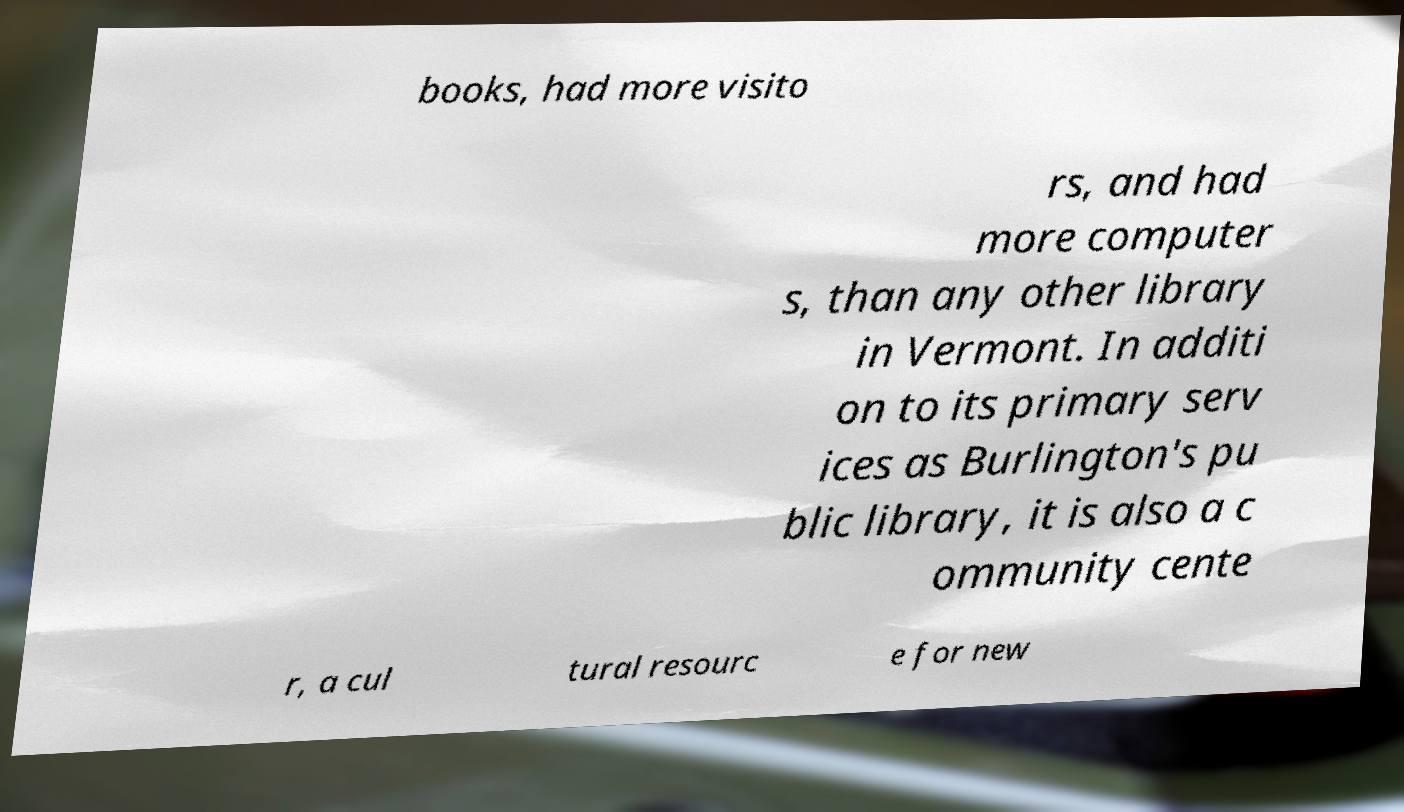What messages or text are displayed in this image? I need them in a readable, typed format. books, had more visito rs, and had more computer s, than any other library in Vermont. In additi on to its primary serv ices as Burlington's pu blic library, it is also a c ommunity cente r, a cul tural resourc e for new 